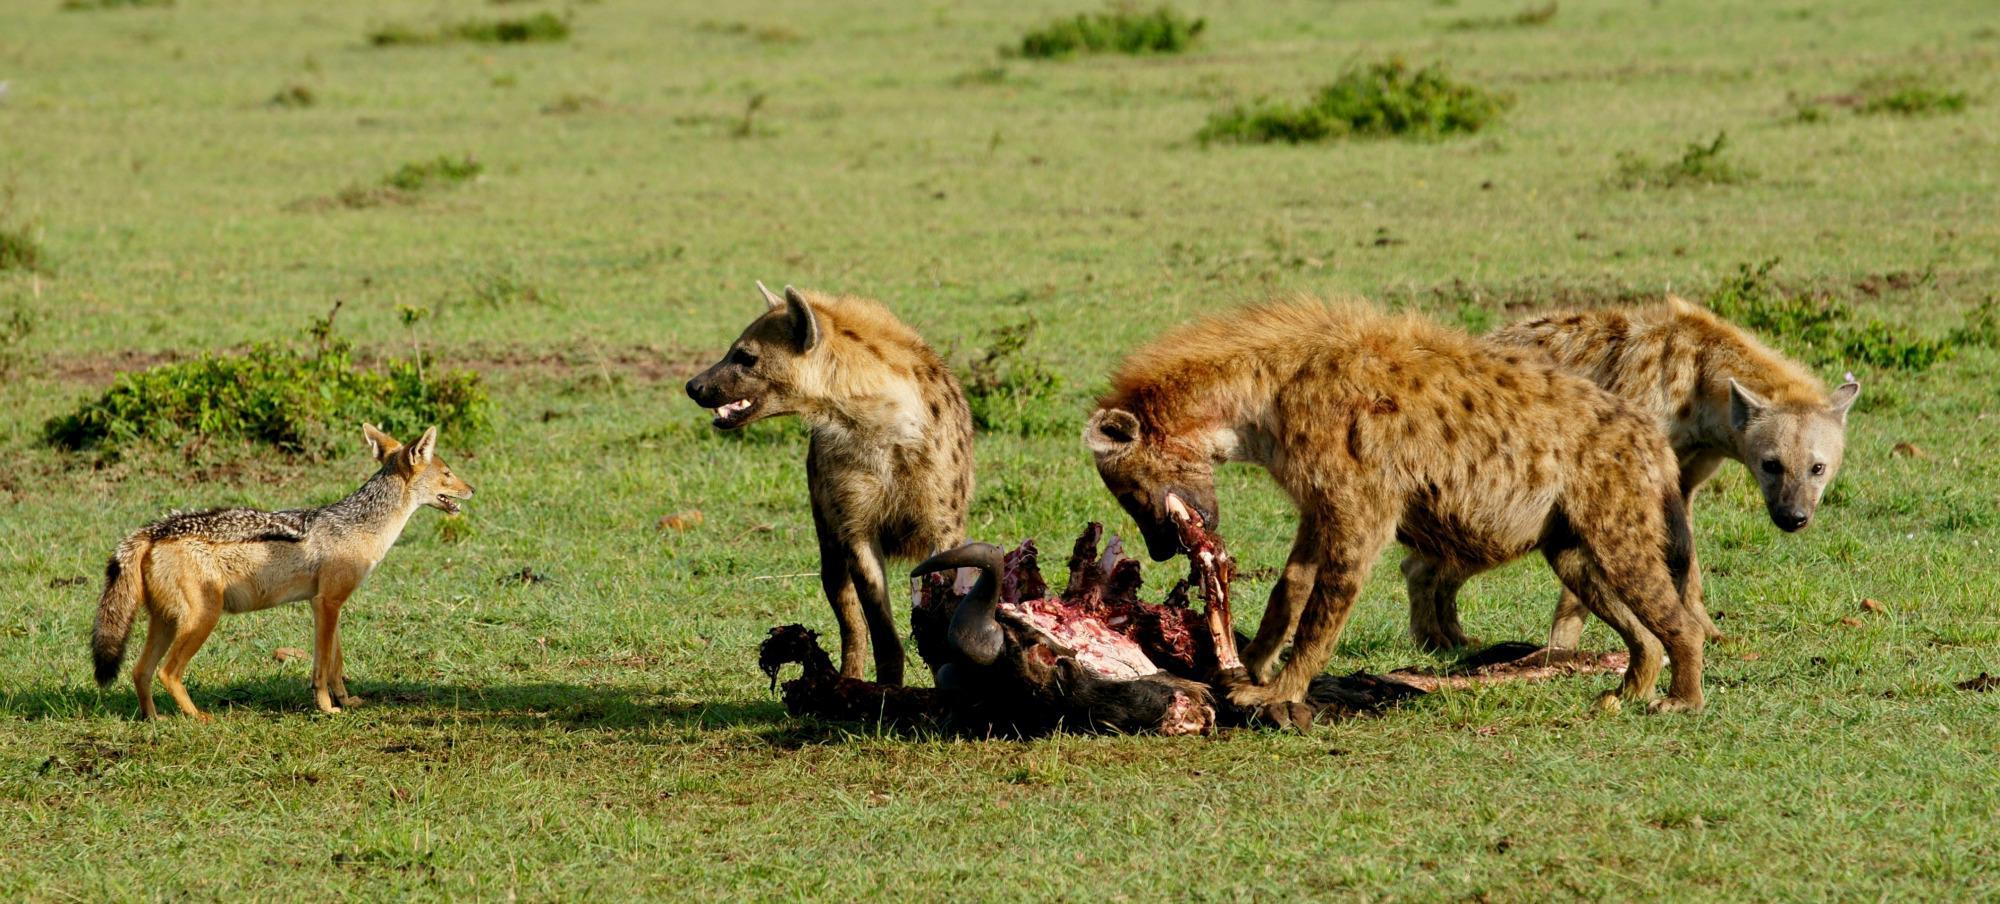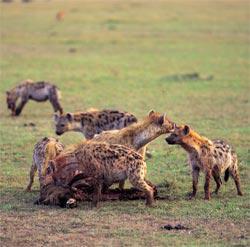The first image is the image on the left, the second image is the image on the right. Examine the images to the left and right. Is the description "The lefthand image includes a predator-type non-hooved animal besides a hyena." accurate? Answer yes or no. Yes. The first image is the image on the left, the second image is the image on the right. Considering the images on both sides, is "There are three hyenas in the left image." valid? Answer yes or no. Yes. 